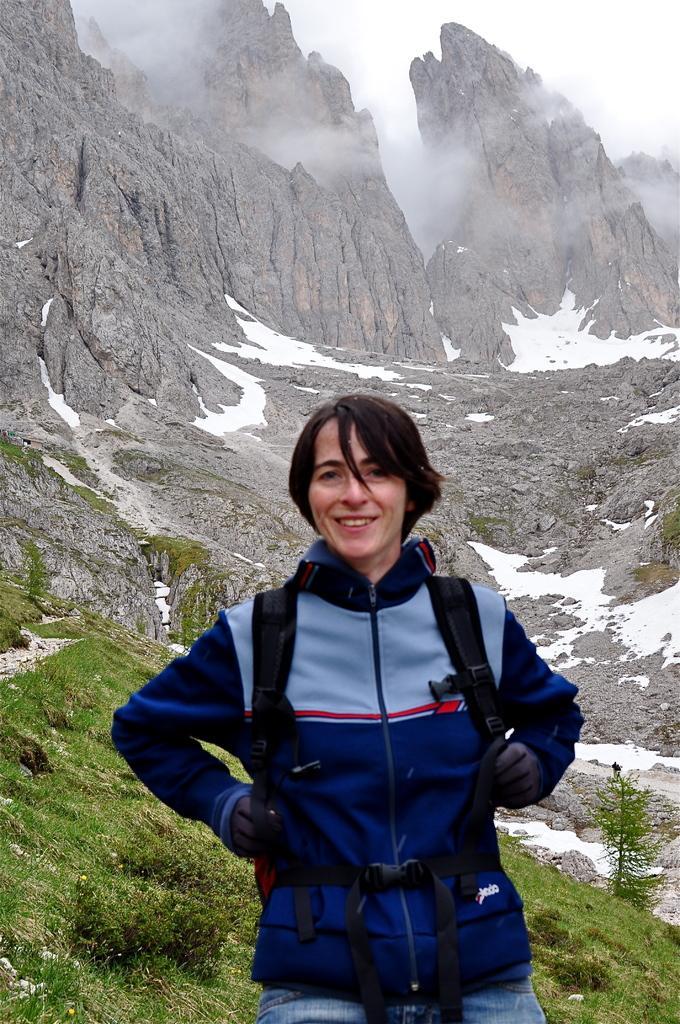Could you give a brief overview of what you see in this image? In this image there is a woman standing. She is wearing a backpack. She is smiling. Behind her there's grass on the hill. In the background there are rocky mountains. There is snow on the mountains. At the top there is the sky. There is fog. 